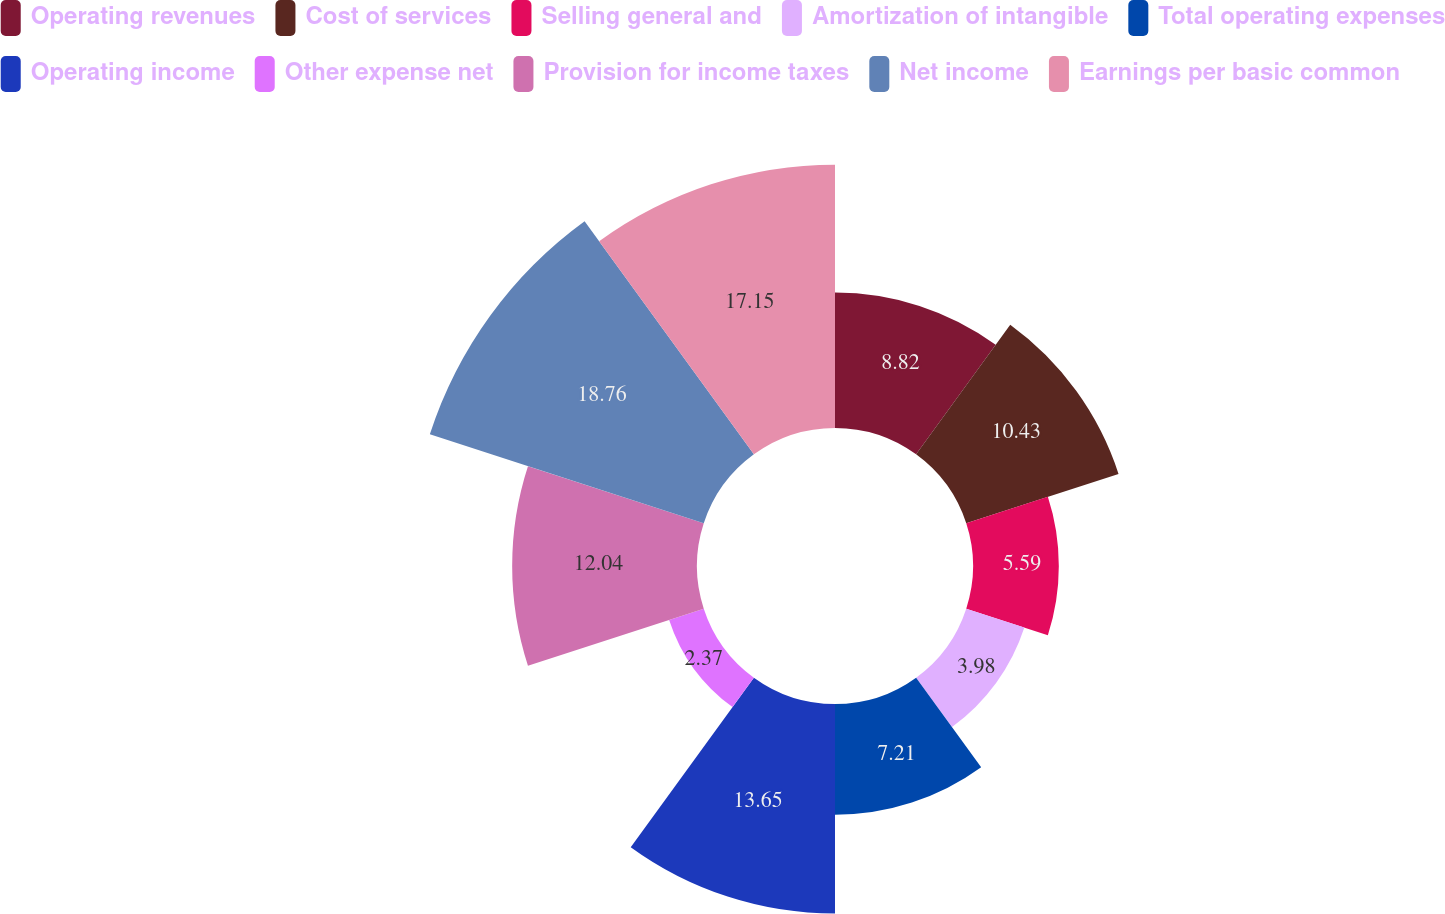<chart> <loc_0><loc_0><loc_500><loc_500><pie_chart><fcel>Operating revenues<fcel>Cost of services<fcel>Selling general and<fcel>Amortization of intangible<fcel>Total operating expenses<fcel>Operating income<fcel>Other expense net<fcel>Provision for income taxes<fcel>Net income<fcel>Earnings per basic common<nl><fcel>8.82%<fcel>10.43%<fcel>5.59%<fcel>3.98%<fcel>7.21%<fcel>13.65%<fcel>2.37%<fcel>12.04%<fcel>18.76%<fcel>17.15%<nl></chart> 